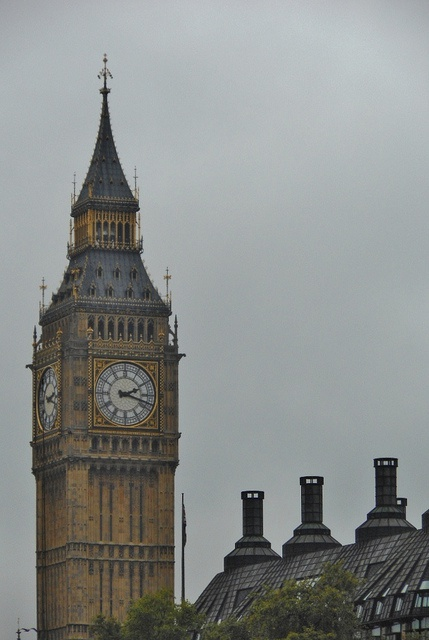Describe the objects in this image and their specific colors. I can see clock in darkgray, gray, and black tones and clock in darkgray, gray, and black tones in this image. 